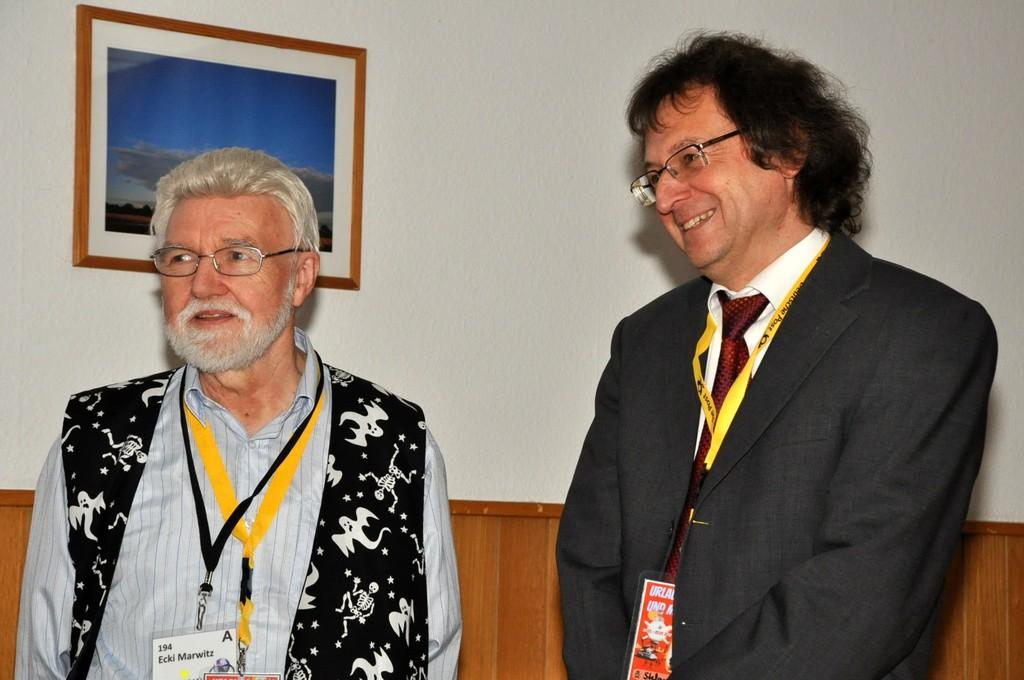How many men are in the image? There are two men in the image. What are the men wearing on their faces? Both men are wearing spectacles. What are the men doing in the image? The men are standing and smiling. What type of clothing might the men be wearing on their upper bodies? One or both men are wearing a blazer. What type of accessory might the men be wearing around their necks? One or both men are wearing a tie. What can be seen on the men's chests? The men have ID cards. What is visible in the background of the image? There is a frame on the wall in the background of the image. What type of bottle is being used to gain knowledge in the image? There is no bottle present in the image, and no indication that knowledge is being gained through any means. 